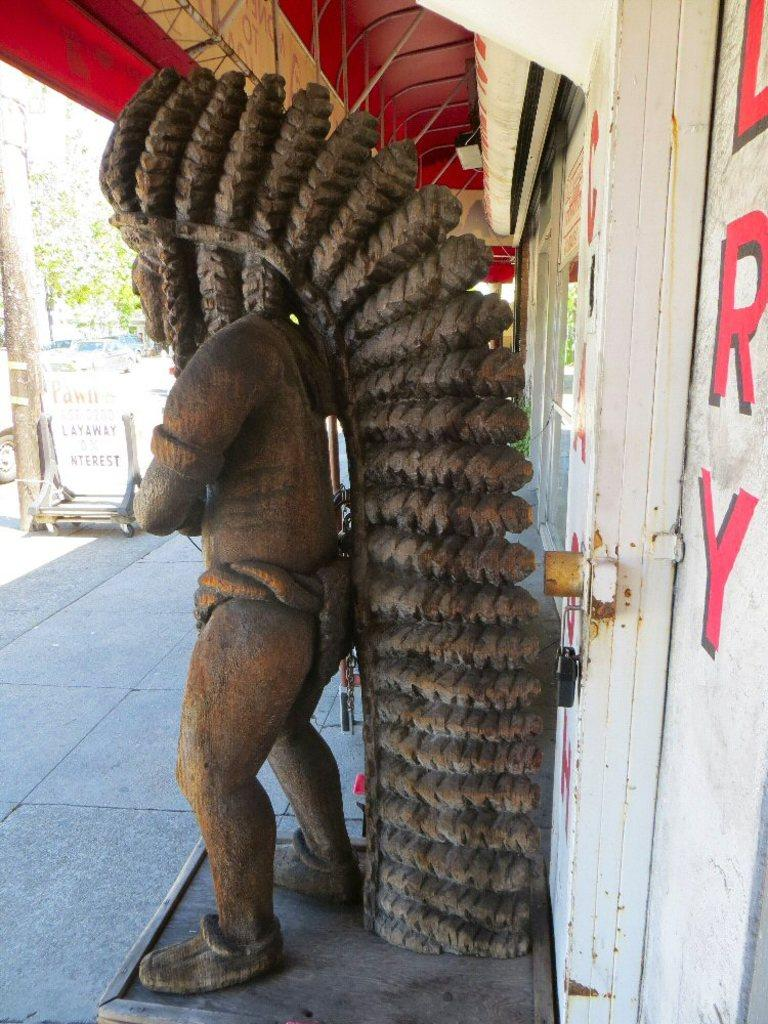What is the main subject in the foreground of the image? There is a person's sculpture in the foreground of the image. What architectural features can be seen in the foreground of the image? There is a door and a rooftop in the foreground of the image. What can be seen in the background of the image? There are trees, a pillar, and a vehicle on the road in the background of the image. What can be inferred about the time of day when the image was taken? The image was likely taken during the day, as there is no indication of darkness or artificial lighting. What type of seat is the cook using in the image? There is no cook or seat present in the image. What items are on the list that the person is holding in the image? There is no list or person holding a list present in the image. 